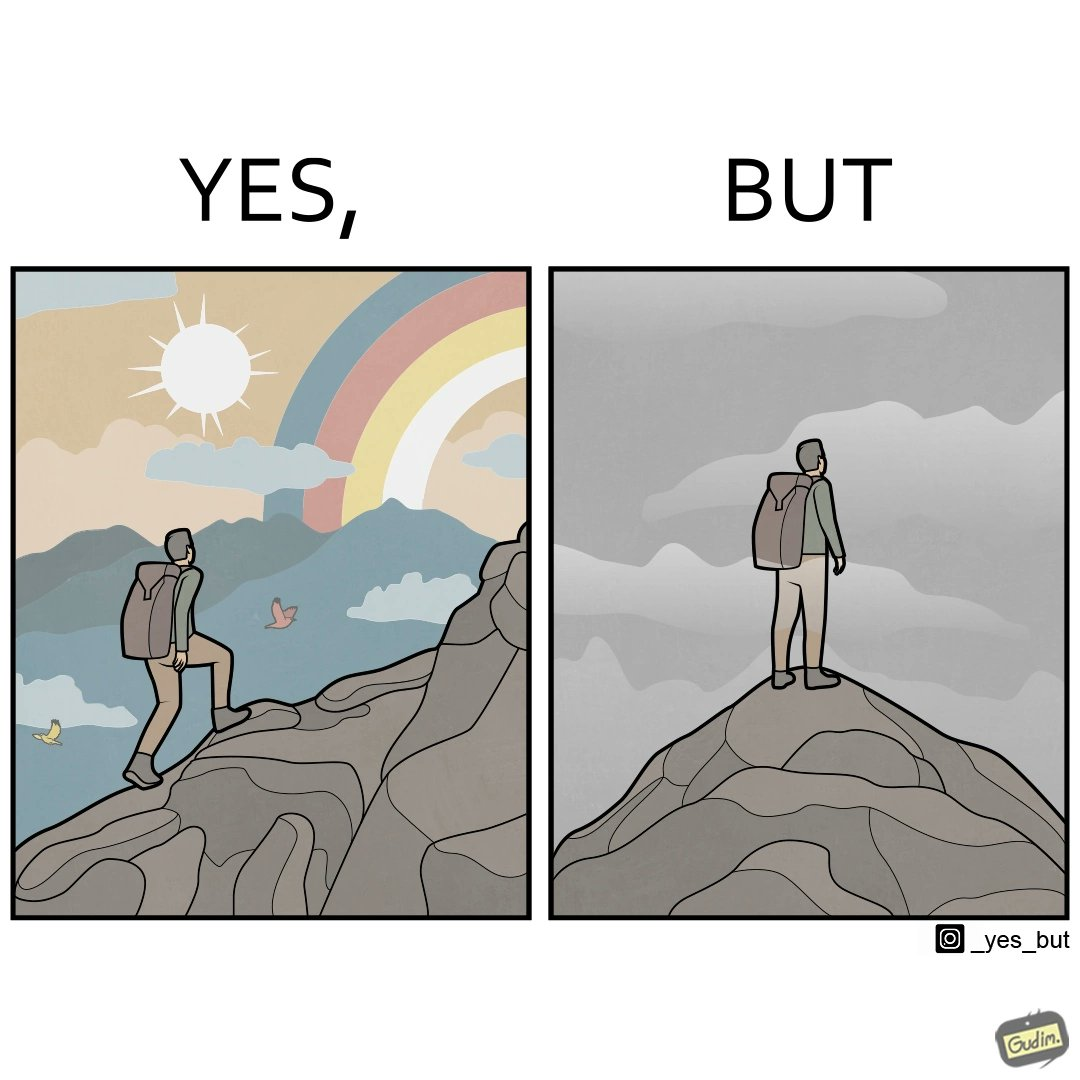Does this image contain satire or humor? Yes, this image is satirical. 